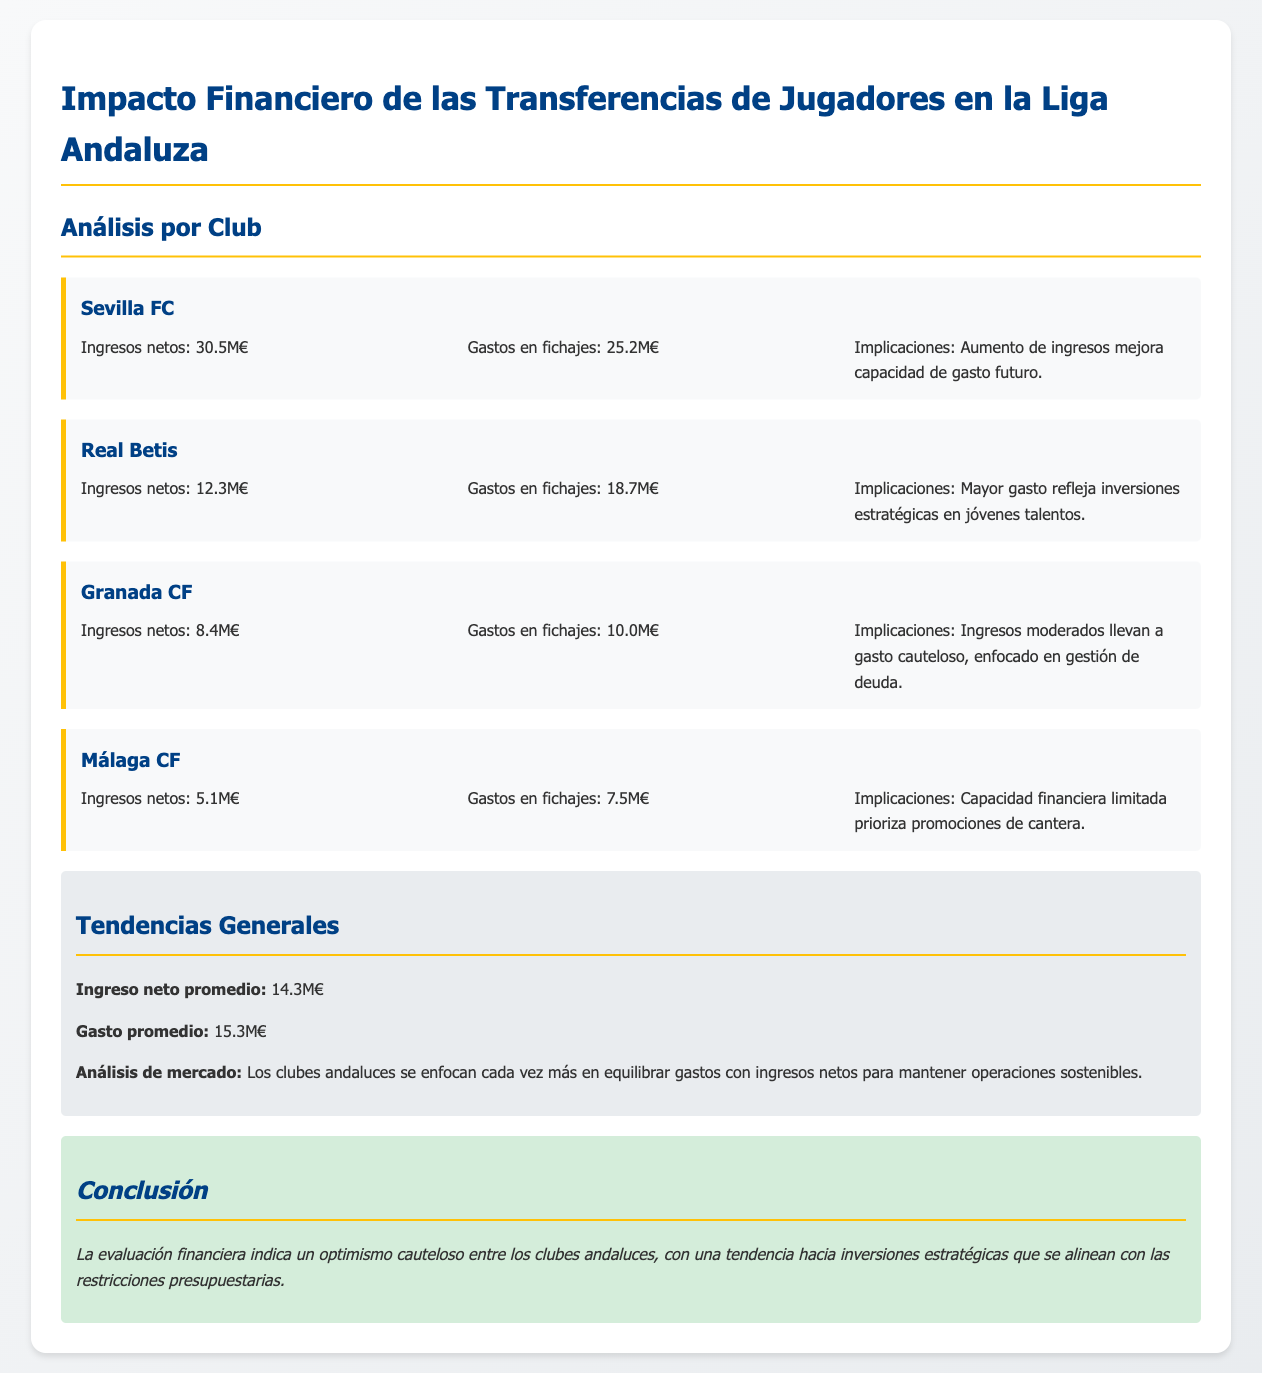what were the net revenues for Sevilla FC? The net revenues for Sevilla FC are explicitly stated in the document as 30.5M€.
Answer: 30.5M€ how much did Real Betis spend on new signings? The expenditure on new signings for Real Betis is 18.7M€ as shown in the financial data.
Answer: 18.7M€ what is the average net income among the clubs? The average net income is calculated from the net revenues of all clubs, which is stated as 14.3M€.
Answer: 14.3M€ which club shows the greatest spending in player transfers? By comparing the expenditure figures, Real Betis shows the greatest spending at 18.7M€.
Answer: Real Betis what is the implication of Sevilla FC's financial situation? The document details that Sevilla FC's increased income improves their future spending capacity.
Answer: Aumento de ingresos mejora capacidad de gasto futuro how does Granada CF's spending relate to its revenues? The document states that Granada CF's revenue of 8.4M€ leads to cautious spending of 10.0M€.
Answer: Gasto cauteloso what is the average expenditure on player transfers among the clubs? The average expenditure on player transfers is explicitly stated as 15.3M€.
Answer: 15.3M€ what strategic focus is noted in the analysis of the clubs? The document highlights that clubs focus increasingly on balancing expenses with net revenues for sustainability.
Answer: Equilibrar gastos con ingresos netos what overall conclusion does the financial report offer? The conclusion drawn in the report emphasizes cautious optimism among Andalusian clubs regarding strategic investments.
Answer: Optimismo cauteloso 